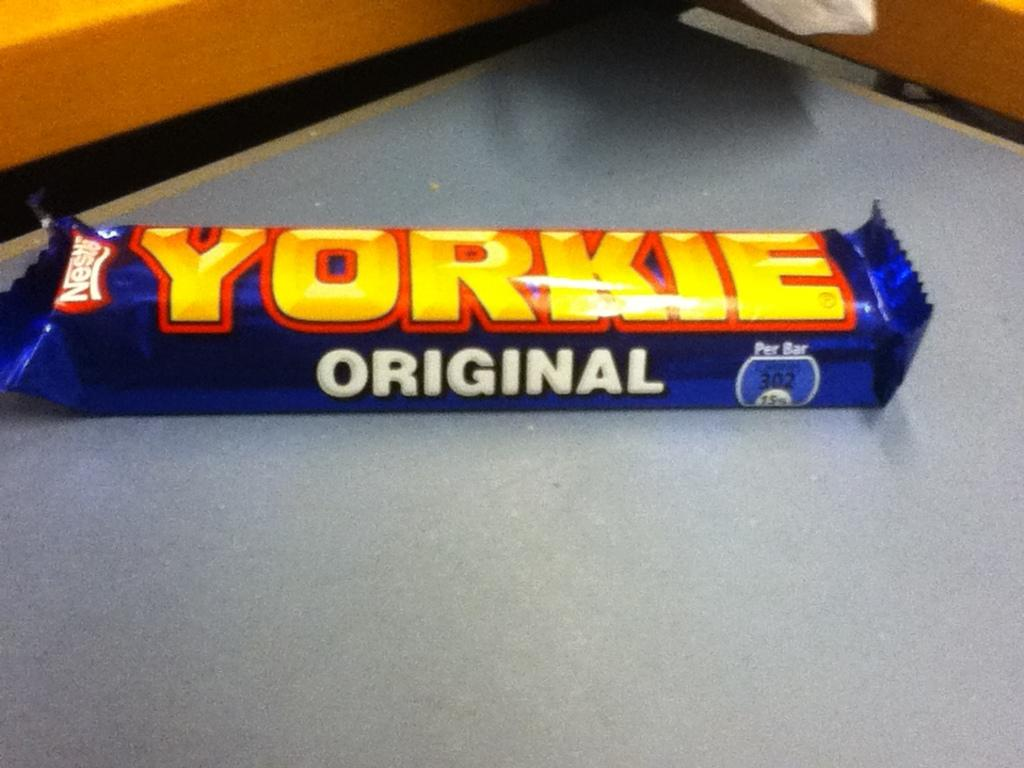<image>
Provide a brief description of the given image. A Yorkies original candy bar sitting on a counter. 